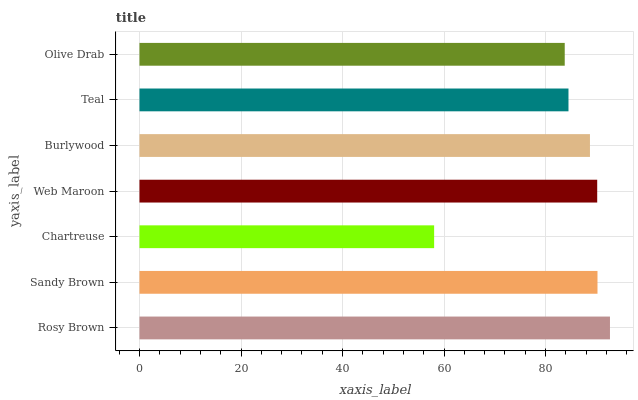Is Chartreuse the minimum?
Answer yes or no. Yes. Is Rosy Brown the maximum?
Answer yes or no. Yes. Is Sandy Brown the minimum?
Answer yes or no. No. Is Sandy Brown the maximum?
Answer yes or no. No. Is Rosy Brown greater than Sandy Brown?
Answer yes or no. Yes. Is Sandy Brown less than Rosy Brown?
Answer yes or no. Yes. Is Sandy Brown greater than Rosy Brown?
Answer yes or no. No. Is Rosy Brown less than Sandy Brown?
Answer yes or no. No. Is Burlywood the high median?
Answer yes or no. Yes. Is Burlywood the low median?
Answer yes or no. Yes. Is Rosy Brown the high median?
Answer yes or no. No. Is Teal the low median?
Answer yes or no. No. 